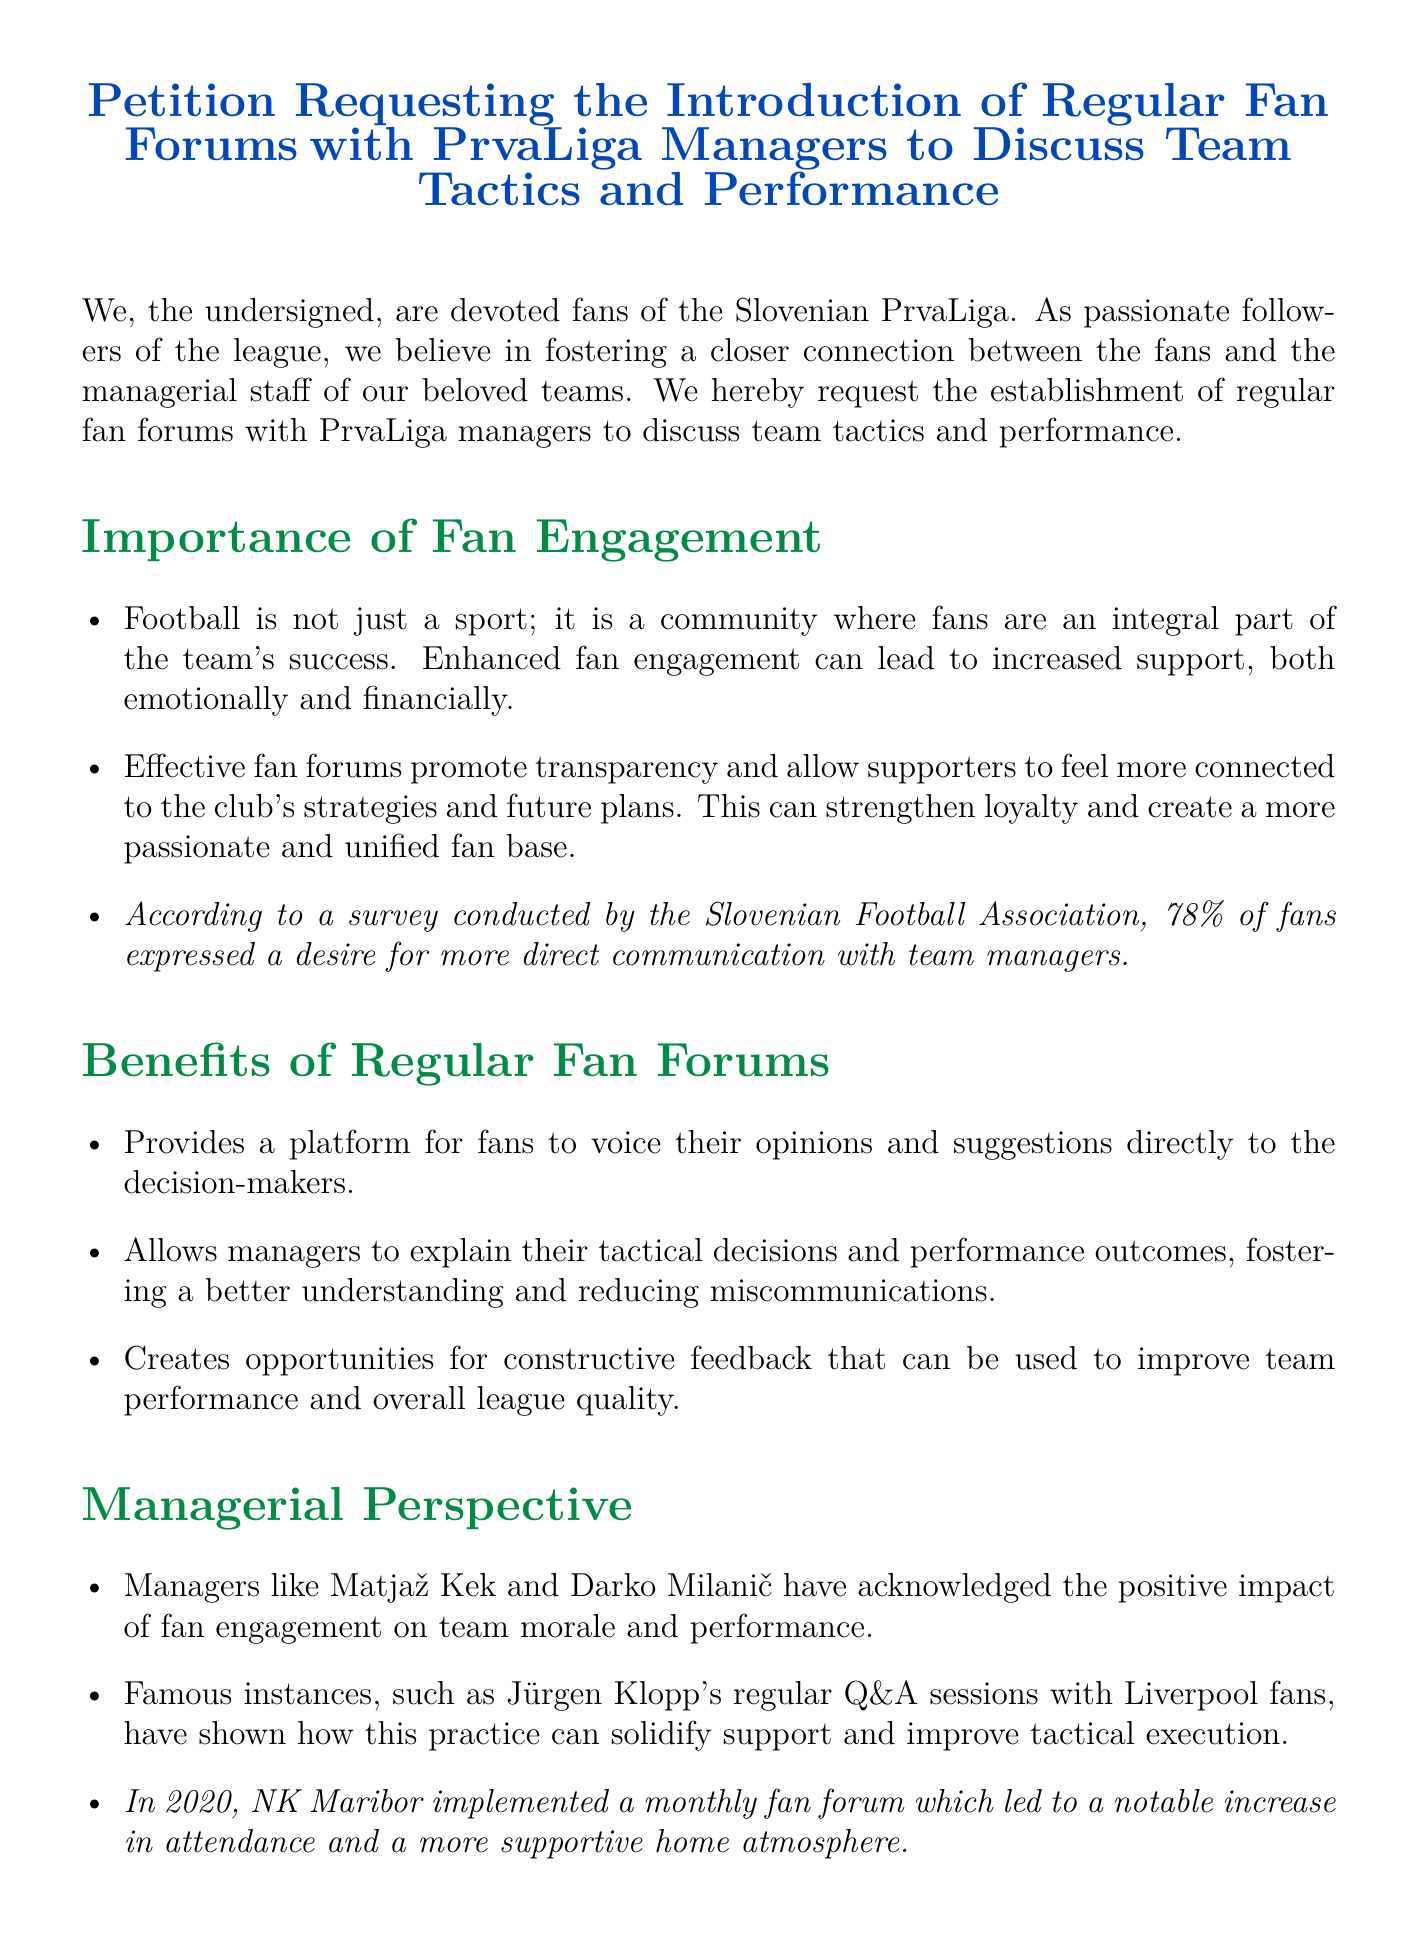What is the title of the petition? The title is "Petition Requesting the Introduction of Regular Fan Forums with PrvaLiga Managers to Discuss Team Tactics and Performance."
Answer: Petition Requesting the Introduction of Regular Fan Forums with PrvaLiga Managers to Discuss Team Tactics and Performance What percentage of fans desire more direct communication with team managers? According to a survey conducted by the Slovenian Football Association, 78% of fans expressed a desire for more direct communication with team managers.
Answer: 78% Who are two managers mentioned in the petition? The petition mentions Matjaž Kek and Darko Milanič as managers acknowledging the positive impact of fan engagement.
Answer: Matjaž Kek and Darko Milanič What year did NK Maribor implement a monthly fan forum? The document states that NK Maribor implemented a monthly fan forum in 2020.
Answer: 2020 What is one proposed frequency for the forums? The petition suggests that regular forums can be scheduled monthly after key fixtures to discuss team performance.
Answer: Monthly What color is associated with the title of the document? The color associated with the title of the document is prvaligablue.
Answer: prvaligablue What is emphasized as a reason for improved team performance? Constructive feedback is highlighted as a means to improve team performance and overall league quality.
Answer: Constructive feedback Who should moderate the forums? The petition proposes that a club representative should moderate the forums to maintain focus and ensure productive dialogue.
Answer: A club representative 